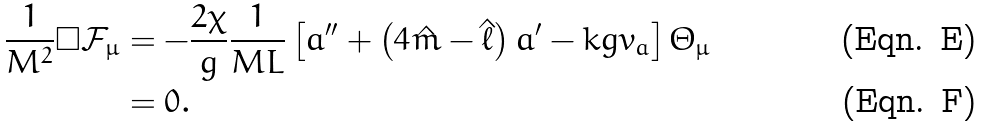Convert formula to latex. <formula><loc_0><loc_0><loc_500><loc_500>\frac { 1 } { M ^ { 2 } } \square \mathcal { F } _ { \mu } & = - \frac { 2 \chi } { g } \frac { 1 } { M L } \left [ a ^ { \prime \prime } + \left ( 4 \hat { m } - \hat { \ell } \right ) a ^ { \prime } - k g v _ { a } \right ] \varTheta _ { \mu } \\ & = 0 .</formula> 